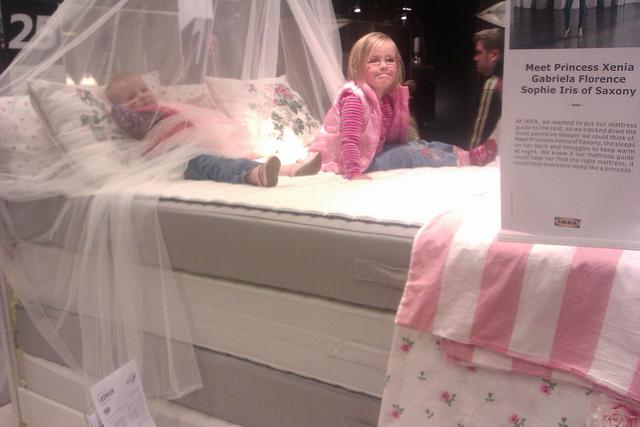Why is there a sign on the bed? price 